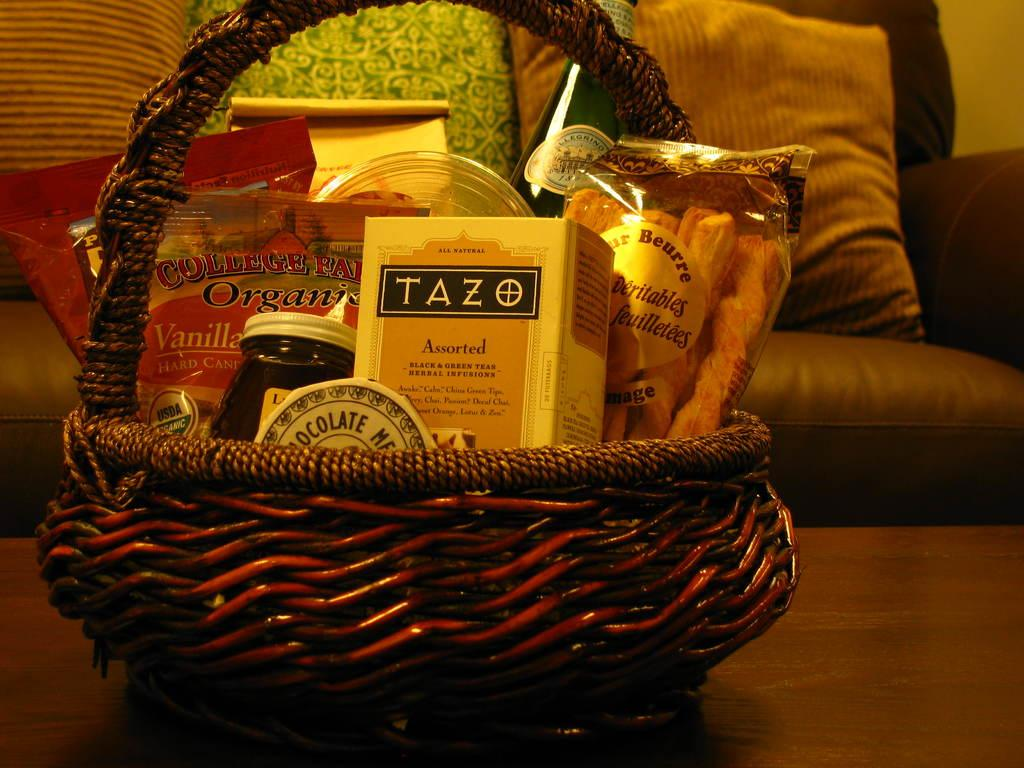What is on the table in the image? There is a basket on the table in the image. What is inside the basket? The basket contains a box, bottles, and packets with food items. What can be seen in the background of the image? There is a couch in the background. What is on the couch? There are pillows on the couch. How many fingers can be seen holding the basket in the image? There are no fingers visible in the image, as the basket is not being held by anyone. Are there any clams present in the image? There are no clams present in the image. 